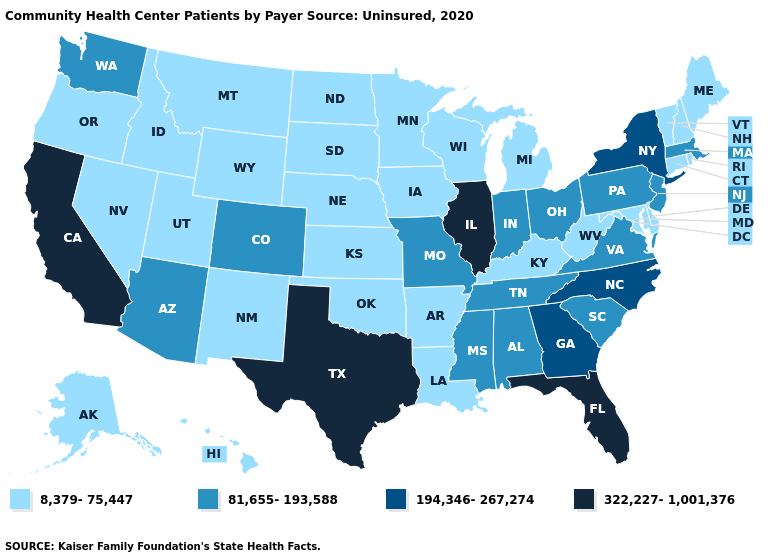What is the value of Florida?
Quick response, please. 322,227-1,001,376. Name the states that have a value in the range 81,655-193,588?
Quick response, please. Alabama, Arizona, Colorado, Indiana, Massachusetts, Mississippi, Missouri, New Jersey, Ohio, Pennsylvania, South Carolina, Tennessee, Virginia, Washington. Name the states that have a value in the range 194,346-267,274?
Concise answer only. Georgia, New York, North Carolina. Does the map have missing data?
Give a very brief answer. No. Name the states that have a value in the range 8,379-75,447?
Short answer required. Alaska, Arkansas, Connecticut, Delaware, Hawaii, Idaho, Iowa, Kansas, Kentucky, Louisiana, Maine, Maryland, Michigan, Minnesota, Montana, Nebraska, Nevada, New Hampshire, New Mexico, North Dakota, Oklahoma, Oregon, Rhode Island, South Dakota, Utah, Vermont, West Virginia, Wisconsin, Wyoming. Name the states that have a value in the range 322,227-1,001,376?
Answer briefly. California, Florida, Illinois, Texas. How many symbols are there in the legend?
Quick response, please. 4. What is the highest value in states that border Maryland?
Write a very short answer. 81,655-193,588. What is the value of Iowa?
Write a very short answer. 8,379-75,447. What is the lowest value in states that border New Jersey?
Quick response, please. 8,379-75,447. What is the value of Nevada?
Quick response, please. 8,379-75,447. Among the states that border Oregon , which have the lowest value?
Concise answer only. Idaho, Nevada. What is the highest value in the USA?
Give a very brief answer. 322,227-1,001,376. Does Arizona have a higher value than Wisconsin?
Write a very short answer. Yes. Does California have the highest value in the West?
Answer briefly. Yes. 